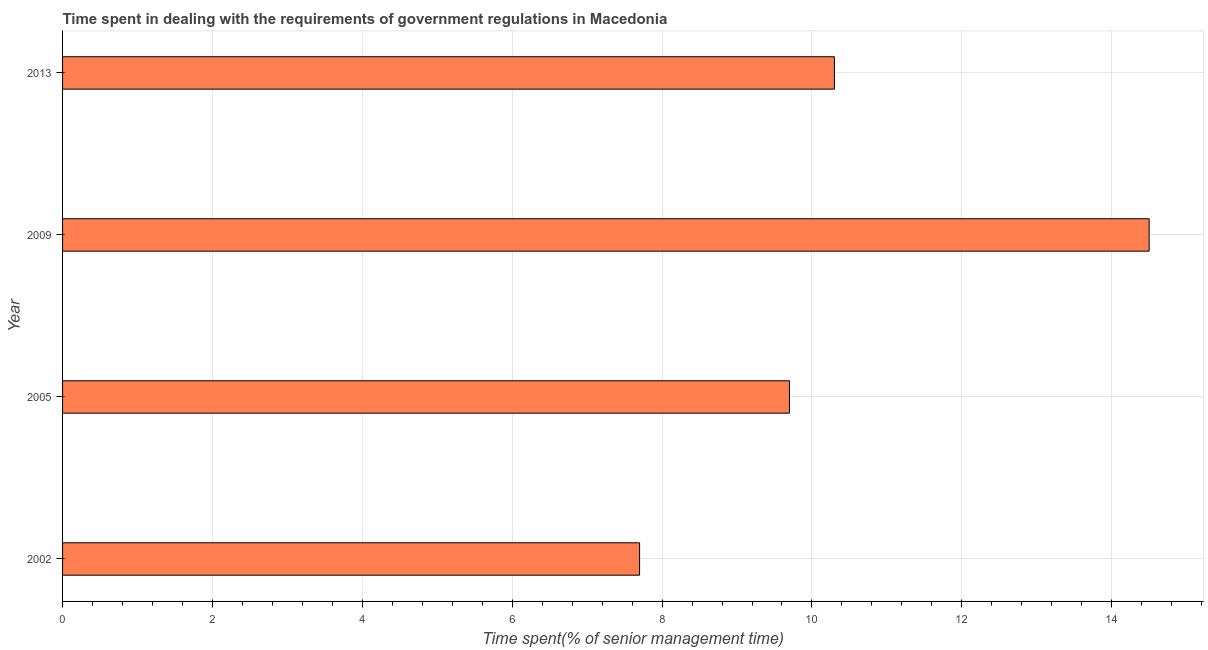What is the title of the graph?
Provide a succinct answer. Time spent in dealing with the requirements of government regulations in Macedonia. What is the label or title of the X-axis?
Offer a very short reply. Time spent(% of senior management time). What is the time spent in dealing with government regulations in 2002?
Ensure brevity in your answer.  7.7. Across all years, what is the maximum time spent in dealing with government regulations?
Provide a succinct answer. 14.5. In which year was the time spent in dealing with government regulations maximum?
Provide a short and direct response. 2009. In which year was the time spent in dealing with government regulations minimum?
Provide a succinct answer. 2002. What is the sum of the time spent in dealing with government regulations?
Provide a short and direct response. 42.2. What is the difference between the time spent in dealing with government regulations in 2002 and 2009?
Your response must be concise. -6.8. What is the average time spent in dealing with government regulations per year?
Offer a very short reply. 10.55. What is the median time spent in dealing with government regulations?
Give a very brief answer. 10. Do a majority of the years between 2009 and 2005 (inclusive) have time spent in dealing with government regulations greater than 12.8 %?
Provide a short and direct response. No. What is the ratio of the time spent in dealing with government regulations in 2002 to that in 2005?
Your answer should be very brief. 0.79. Is the time spent in dealing with government regulations in 2005 less than that in 2009?
Your answer should be compact. Yes. Is the sum of the time spent in dealing with government regulations in 2002 and 2013 greater than the maximum time spent in dealing with government regulations across all years?
Make the answer very short. Yes. In how many years, is the time spent in dealing with government regulations greater than the average time spent in dealing with government regulations taken over all years?
Provide a short and direct response. 1. How many bars are there?
Provide a short and direct response. 4. Are the values on the major ticks of X-axis written in scientific E-notation?
Your answer should be very brief. No. What is the Time spent(% of senior management time) of 2002?
Your answer should be very brief. 7.7. What is the Time spent(% of senior management time) of 2005?
Provide a succinct answer. 9.7. What is the Time spent(% of senior management time) of 2009?
Your answer should be very brief. 14.5. What is the Time spent(% of senior management time) of 2013?
Your answer should be very brief. 10.3. What is the difference between the Time spent(% of senior management time) in 2002 and 2009?
Make the answer very short. -6.8. What is the difference between the Time spent(% of senior management time) in 2002 and 2013?
Your answer should be compact. -2.6. What is the difference between the Time spent(% of senior management time) in 2005 and 2013?
Offer a very short reply. -0.6. What is the ratio of the Time spent(% of senior management time) in 2002 to that in 2005?
Give a very brief answer. 0.79. What is the ratio of the Time spent(% of senior management time) in 2002 to that in 2009?
Offer a terse response. 0.53. What is the ratio of the Time spent(% of senior management time) in 2002 to that in 2013?
Your answer should be compact. 0.75. What is the ratio of the Time spent(% of senior management time) in 2005 to that in 2009?
Your response must be concise. 0.67. What is the ratio of the Time spent(% of senior management time) in 2005 to that in 2013?
Ensure brevity in your answer.  0.94. What is the ratio of the Time spent(% of senior management time) in 2009 to that in 2013?
Provide a succinct answer. 1.41. 